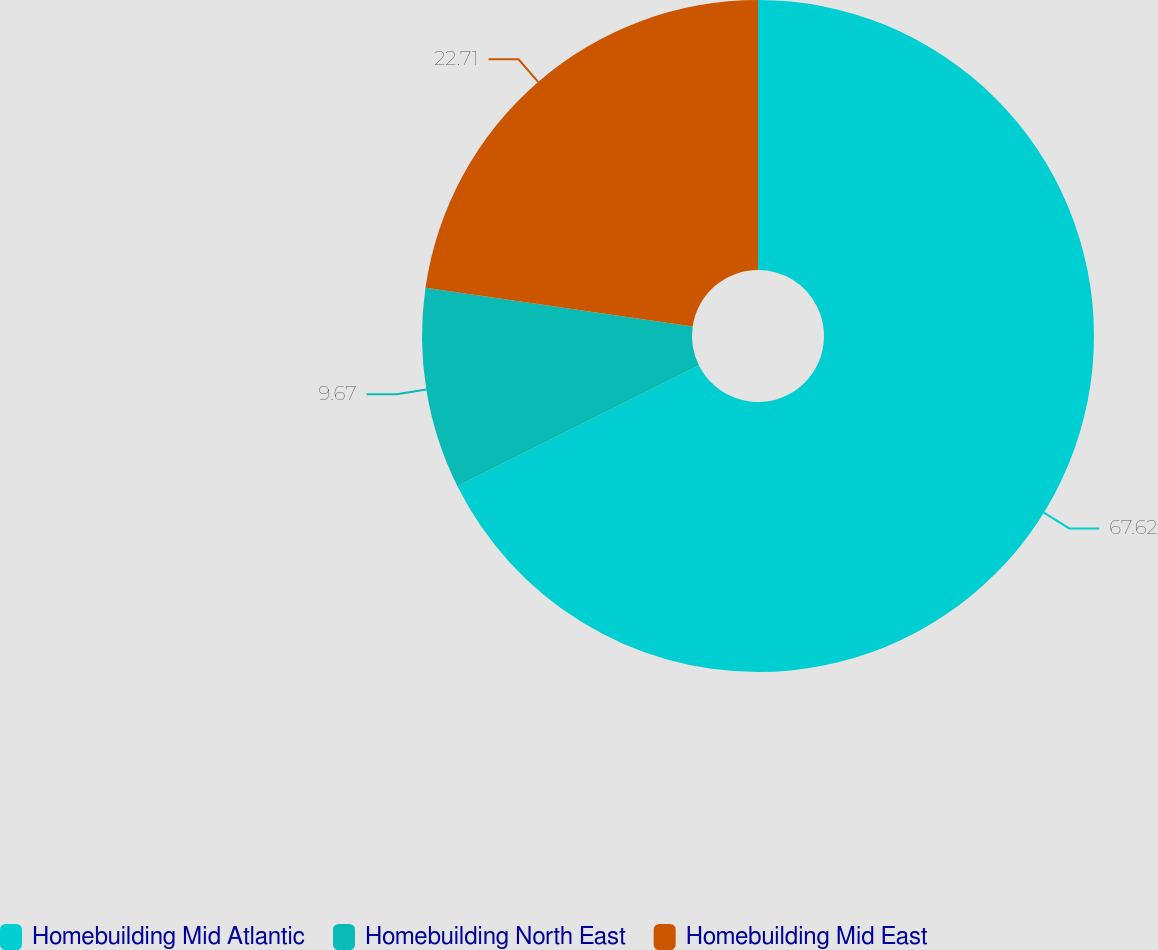Convert chart. <chart><loc_0><loc_0><loc_500><loc_500><pie_chart><fcel>Homebuilding Mid Atlantic<fcel>Homebuilding North East<fcel>Homebuilding Mid East<nl><fcel>67.63%<fcel>9.67%<fcel>22.71%<nl></chart> 